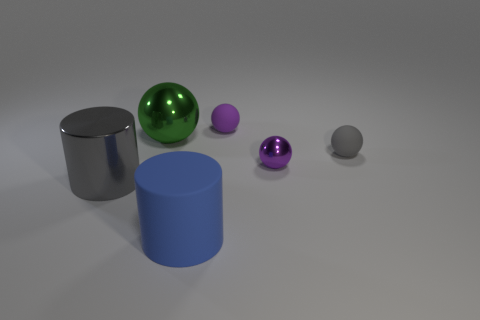Subtract all tiny purple metallic balls. How many balls are left? 3 Subtract all gray balls. How many balls are left? 3 Add 2 shiny cylinders. How many objects exist? 8 Subtract all big gray metallic objects. Subtract all tiny purple objects. How many objects are left? 3 Add 3 small purple metallic objects. How many small purple metallic objects are left? 4 Add 4 large gray rubber balls. How many large gray rubber balls exist? 4 Subtract 0 brown cubes. How many objects are left? 6 Subtract all cylinders. How many objects are left? 4 Subtract all gray cylinders. Subtract all green blocks. How many cylinders are left? 1 Subtract all gray cylinders. How many green balls are left? 1 